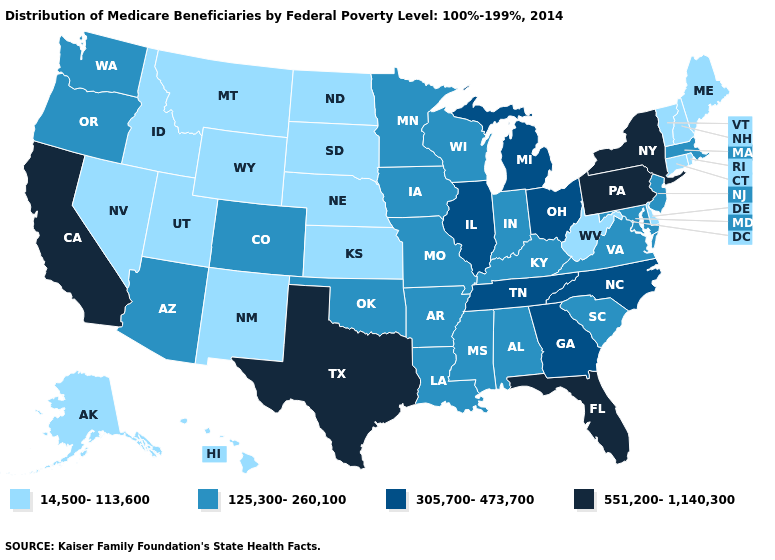What is the value of California?
Be succinct. 551,200-1,140,300. What is the value of Alaska?
Concise answer only. 14,500-113,600. Which states have the lowest value in the West?
Concise answer only. Alaska, Hawaii, Idaho, Montana, Nevada, New Mexico, Utah, Wyoming. Among the states that border Mississippi , which have the highest value?
Answer briefly. Tennessee. Does Utah have the lowest value in the West?
Short answer required. Yes. Which states have the lowest value in the South?
Quick response, please. Delaware, West Virginia. Does Vermont have the same value as Alabama?
Keep it brief. No. What is the value of Maine?
Concise answer only. 14,500-113,600. Name the states that have a value in the range 551,200-1,140,300?
Write a very short answer. California, Florida, New York, Pennsylvania, Texas. What is the value of Pennsylvania?
Write a very short answer. 551,200-1,140,300. What is the lowest value in the USA?
Keep it brief. 14,500-113,600. Does New Hampshire have the highest value in the Northeast?
Be succinct. No. Name the states that have a value in the range 14,500-113,600?
Write a very short answer. Alaska, Connecticut, Delaware, Hawaii, Idaho, Kansas, Maine, Montana, Nebraska, Nevada, New Hampshire, New Mexico, North Dakota, Rhode Island, South Dakota, Utah, Vermont, West Virginia, Wyoming. What is the value of Louisiana?
Short answer required. 125,300-260,100. Does the map have missing data?
Answer briefly. No. 